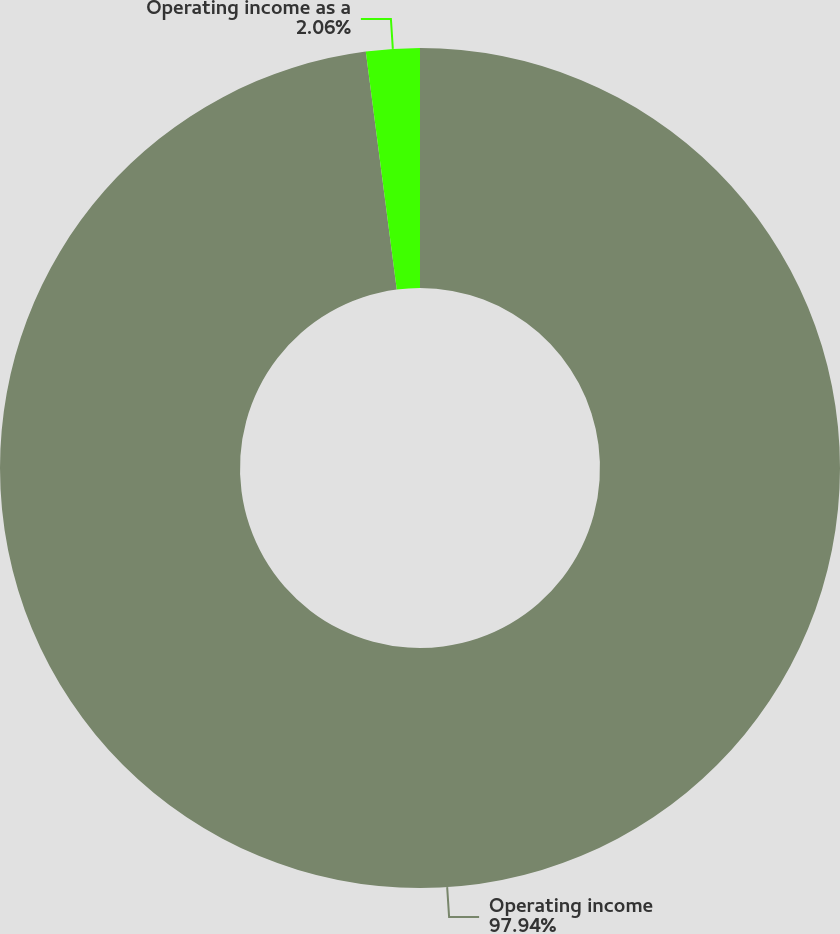Convert chart to OTSL. <chart><loc_0><loc_0><loc_500><loc_500><pie_chart><fcel>Operating income<fcel>Operating income as a<nl><fcel>97.94%<fcel>2.06%<nl></chart> 